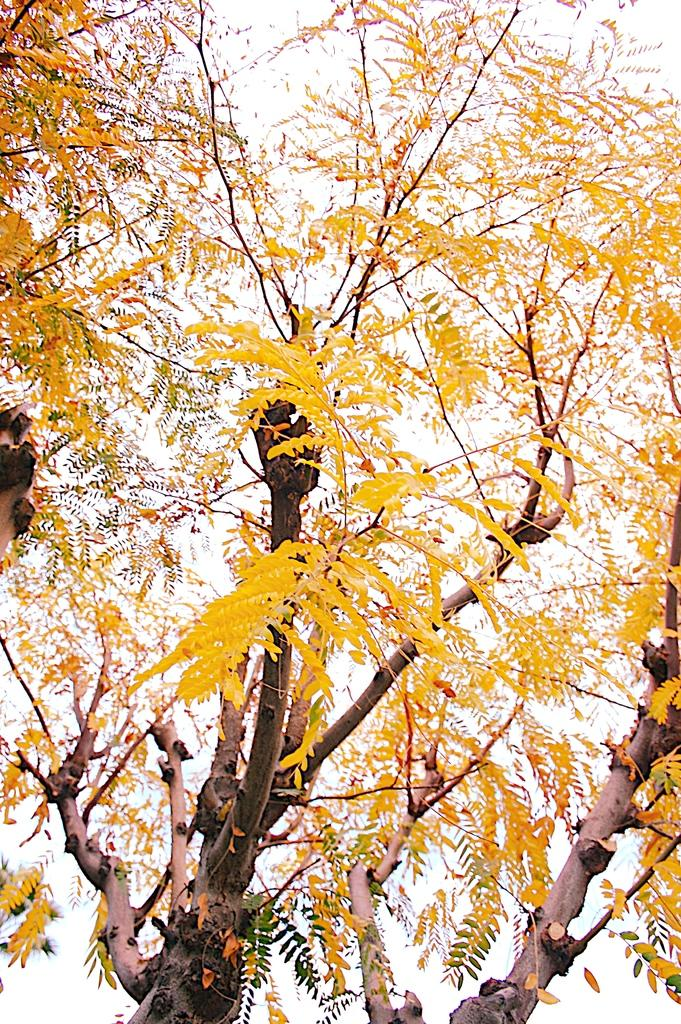What type of vegetation can be seen in the image? There are trees in the image. What part of the natural environment is visible in the image? The sky is visible in the image. How many lines can be seen in the image? There is no specific mention of lines in the image, so it is not possible to determine the number of lines present. 